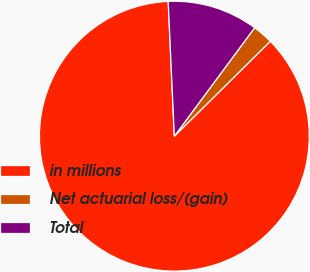<chart> <loc_0><loc_0><loc_500><loc_500><pie_chart><fcel>in millions<fcel>Net actuarial loss/(gain)<fcel>Total<nl><fcel>86.69%<fcel>2.44%<fcel>10.87%<nl></chart> 